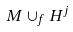Convert formula to latex. <formula><loc_0><loc_0><loc_500><loc_500>M \cup _ { f } H ^ { j }</formula> 